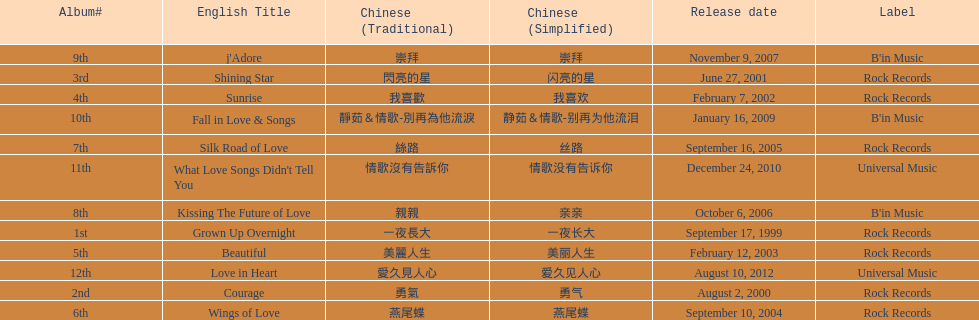Parse the table in full. {'header': ['Album#', 'English Title', 'Chinese (Traditional)', 'Chinese (Simplified)', 'Release date', 'Label'], 'rows': [['9th', "j'Adore", '崇拜', '崇拜', 'November 9, 2007', "B'in Music"], ['3rd', 'Shining Star', '閃亮的星', '闪亮的星', 'June 27, 2001', 'Rock Records'], ['4th', 'Sunrise', '我喜歡', '我喜欢', 'February 7, 2002', 'Rock Records'], ['10th', 'Fall in Love & Songs', '靜茹＆情歌-別再為他流淚', '静茹＆情歌-别再为他流泪', 'January 16, 2009', "B'in Music"], ['7th', 'Silk Road of Love', '絲路', '丝路', 'September 16, 2005', 'Rock Records'], ['11th', "What Love Songs Didn't Tell You", '情歌沒有告訴你', '情歌没有告诉你', 'December 24, 2010', 'Universal Music'], ['8th', 'Kissing The Future of Love', '親親', '亲亲', 'October 6, 2006', "B'in Music"], ['1st', 'Grown Up Overnight', '一夜長大', '一夜长大', 'September 17, 1999', 'Rock Records'], ['5th', 'Beautiful', '美麗人生', '美丽人生', 'February 12, 2003', 'Rock Records'], ['12th', 'Love in Heart', '愛久見人心', '爱久见人心', 'August 10, 2012', 'Universal Music'], ['2nd', 'Courage', '勇氣', '勇气', 'August 2, 2000', 'Rock Records'], ['6th', 'Wings of Love', '燕尾蝶', '燕尾蝶', 'September 10, 2004', 'Rock Records']]} What label was she working with before universal music? B'in Music. 